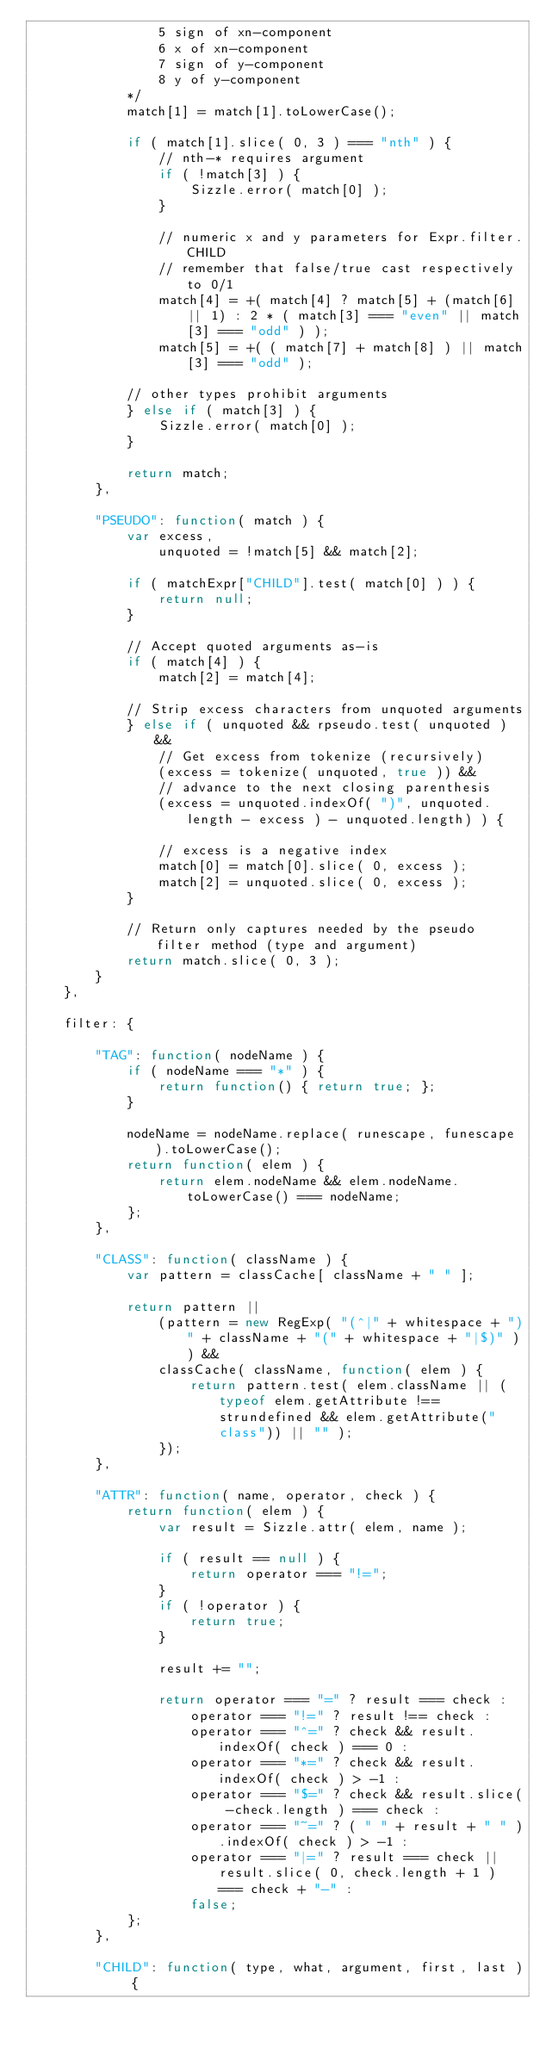Convert code to text. <code><loc_0><loc_0><loc_500><loc_500><_JavaScript_>				5 sign of xn-component
				6 x of xn-component
				7 sign of y-component
				8 y of y-component
			*/
			match[1] = match[1].toLowerCase();

			if ( match[1].slice( 0, 3 ) === "nth" ) {
				// nth-* requires argument
				if ( !match[3] ) {
					Sizzle.error( match[0] );
				}

				// numeric x and y parameters for Expr.filter.CHILD
				// remember that false/true cast respectively to 0/1
				match[4] = +( match[4] ? match[5] + (match[6] || 1) : 2 * ( match[3] === "even" || match[3] === "odd" ) );
				match[5] = +( ( match[7] + match[8] ) || match[3] === "odd" );

			// other types prohibit arguments
			} else if ( match[3] ) {
				Sizzle.error( match[0] );
			}

			return match;
		},

		"PSEUDO": function( match ) {
			var excess,
				unquoted = !match[5] && match[2];

			if ( matchExpr["CHILD"].test( match[0] ) ) {
				return null;
			}

			// Accept quoted arguments as-is
			if ( match[4] ) {
				match[2] = match[4];

			// Strip excess characters from unquoted arguments
			} else if ( unquoted && rpseudo.test( unquoted ) &&
				// Get excess from tokenize (recursively)
				(excess = tokenize( unquoted, true )) &&
				// advance to the next closing parenthesis
				(excess = unquoted.indexOf( ")", unquoted.length - excess ) - unquoted.length) ) {

				// excess is a negative index
				match[0] = match[0].slice( 0, excess );
				match[2] = unquoted.slice( 0, excess );
			}

			// Return only captures needed by the pseudo filter method (type and argument)
			return match.slice( 0, 3 );
		}
	},

	filter: {

		"TAG": function( nodeName ) {
			if ( nodeName === "*" ) {
				return function() { return true; };
			}

			nodeName = nodeName.replace( runescape, funescape ).toLowerCase();
			return function( elem ) {
				return elem.nodeName && elem.nodeName.toLowerCase() === nodeName;
			};
		},

		"CLASS": function( className ) {
			var pattern = classCache[ className + " " ];

			return pattern ||
				(pattern = new RegExp( "(^|" + whitespace + ")" + className + "(" + whitespace + "|$)" )) &&
				classCache( className, function( elem ) {
					return pattern.test( elem.className || (typeof elem.getAttribute !== strundefined && elem.getAttribute("class")) || "" );
				});
		},

		"ATTR": function( name, operator, check ) {
			return function( elem ) {
				var result = Sizzle.attr( elem, name );

				if ( result == null ) {
					return operator === "!=";
				}
				if ( !operator ) {
					return true;
				}

				result += "";

				return operator === "=" ? result === check :
					operator === "!=" ? result !== check :
					operator === "^=" ? check && result.indexOf( check ) === 0 :
					operator === "*=" ? check && result.indexOf( check ) > -1 :
					operator === "$=" ? check && result.slice( -check.length ) === check :
					operator === "~=" ? ( " " + result + " " ).indexOf( check ) > -1 :
					operator === "|=" ? result === check || result.slice( 0, check.length + 1 ) === check + "-" :
					false;
			};
		},

		"CHILD": function( type, what, argument, first, last ) {</code> 